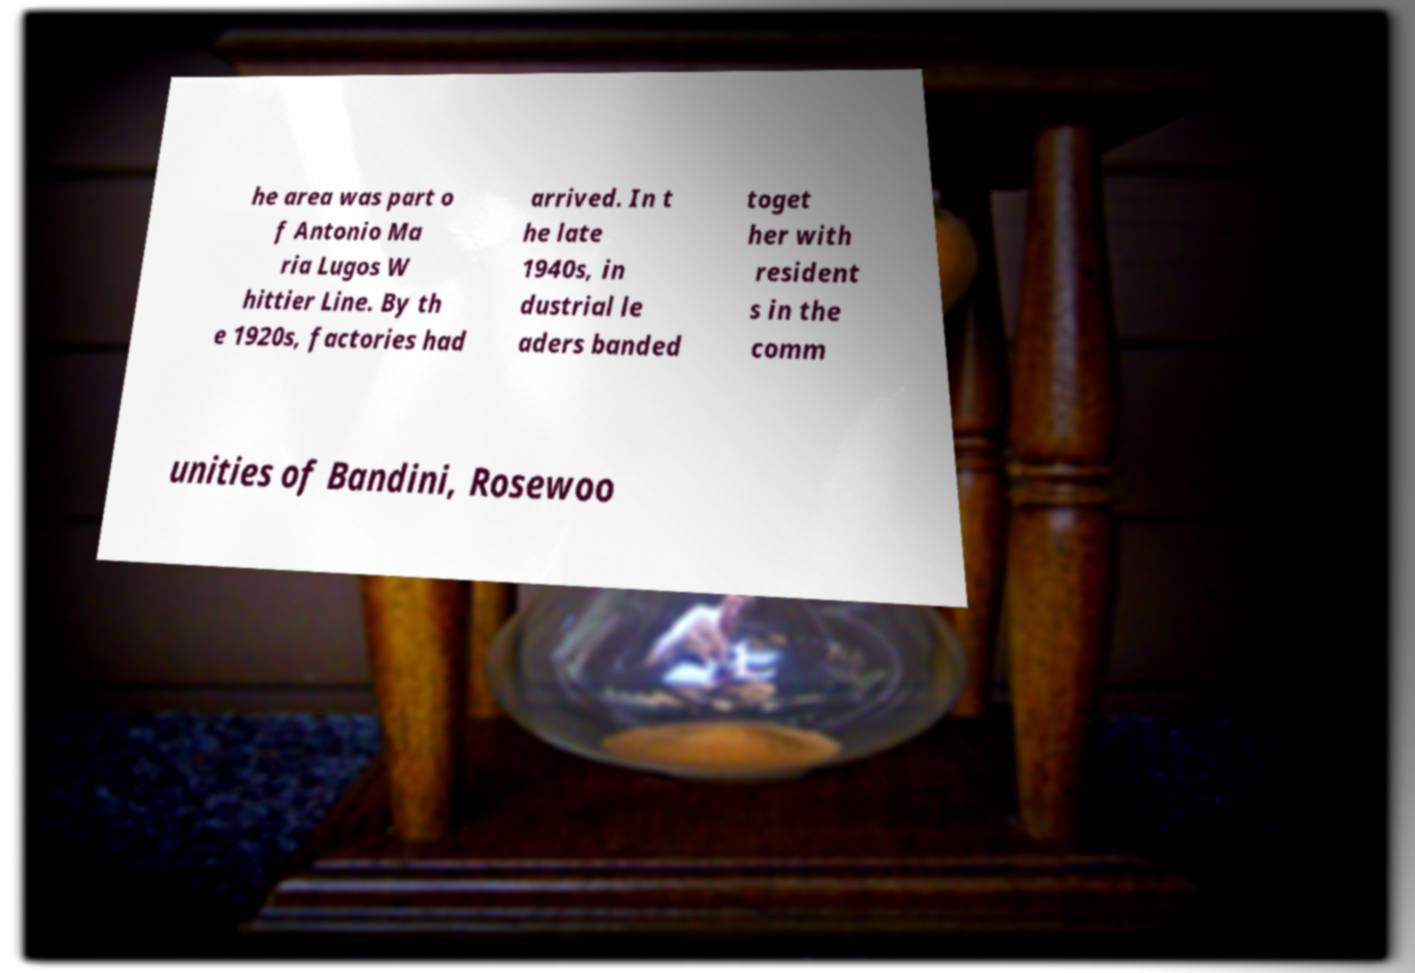Please identify and transcribe the text found in this image. he area was part o f Antonio Ma ria Lugos W hittier Line. By th e 1920s, factories had arrived. In t he late 1940s, in dustrial le aders banded toget her with resident s in the comm unities of Bandini, Rosewoo 